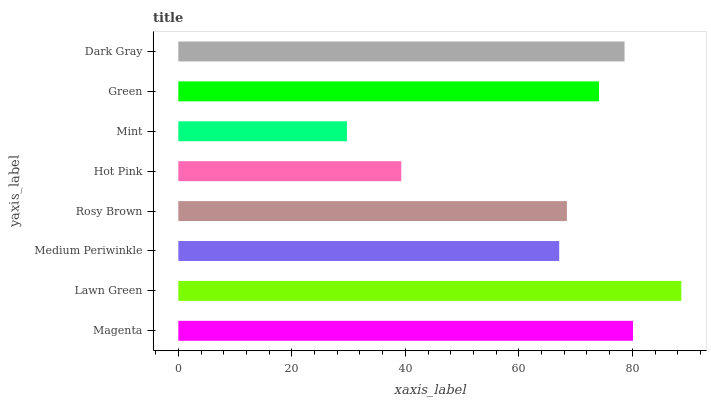Is Mint the minimum?
Answer yes or no. Yes. Is Lawn Green the maximum?
Answer yes or no. Yes. Is Medium Periwinkle the minimum?
Answer yes or no. No. Is Medium Periwinkle the maximum?
Answer yes or no. No. Is Lawn Green greater than Medium Periwinkle?
Answer yes or no. Yes. Is Medium Periwinkle less than Lawn Green?
Answer yes or no. Yes. Is Medium Periwinkle greater than Lawn Green?
Answer yes or no. No. Is Lawn Green less than Medium Periwinkle?
Answer yes or no. No. Is Green the high median?
Answer yes or no. Yes. Is Rosy Brown the low median?
Answer yes or no. Yes. Is Magenta the high median?
Answer yes or no. No. Is Mint the low median?
Answer yes or no. No. 